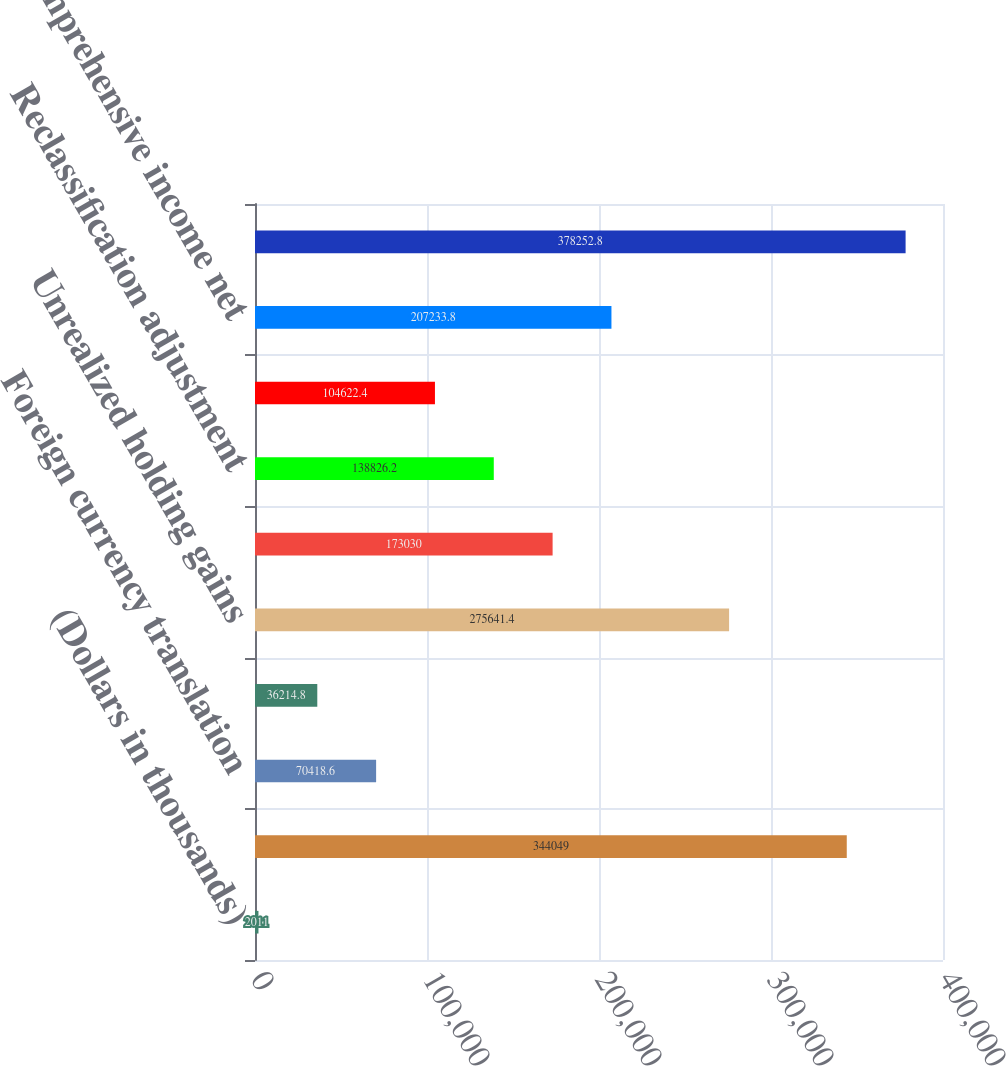Convert chart to OTSL. <chart><loc_0><loc_0><loc_500><loc_500><bar_chart><fcel>(Dollars in thousands)<fcel>Net income before<fcel>Foreign currency translation<fcel>Related tax benefit (expense)<fcel>Unrealized holding gains<fcel>Related tax expense<fcel>Reclassification adjustment<fcel>Related tax benefit<fcel>Other comprehensive income net<fcel>Comprehensive income<nl><fcel>2011<fcel>344049<fcel>70418.6<fcel>36214.8<fcel>275641<fcel>173030<fcel>138826<fcel>104622<fcel>207234<fcel>378253<nl></chart> 